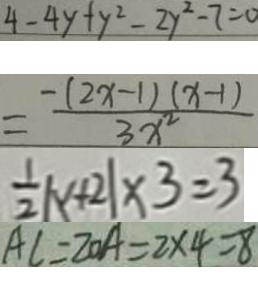Convert formula to latex. <formula><loc_0><loc_0><loc_500><loc_500>4 - 4 y + y ^ { 2 } - 2 y ^ { 2 } - 7 = 0 
 = \frac { - ( 2 x - 1 ) ( x - 1 ) } { 3 x ^ { 2 } } 
 \frac { 1 } { 2 } \vert x + 2 \vert \times 3 = 3 
 A C = 2 0 A = 2 \times 4 = 8</formula> 